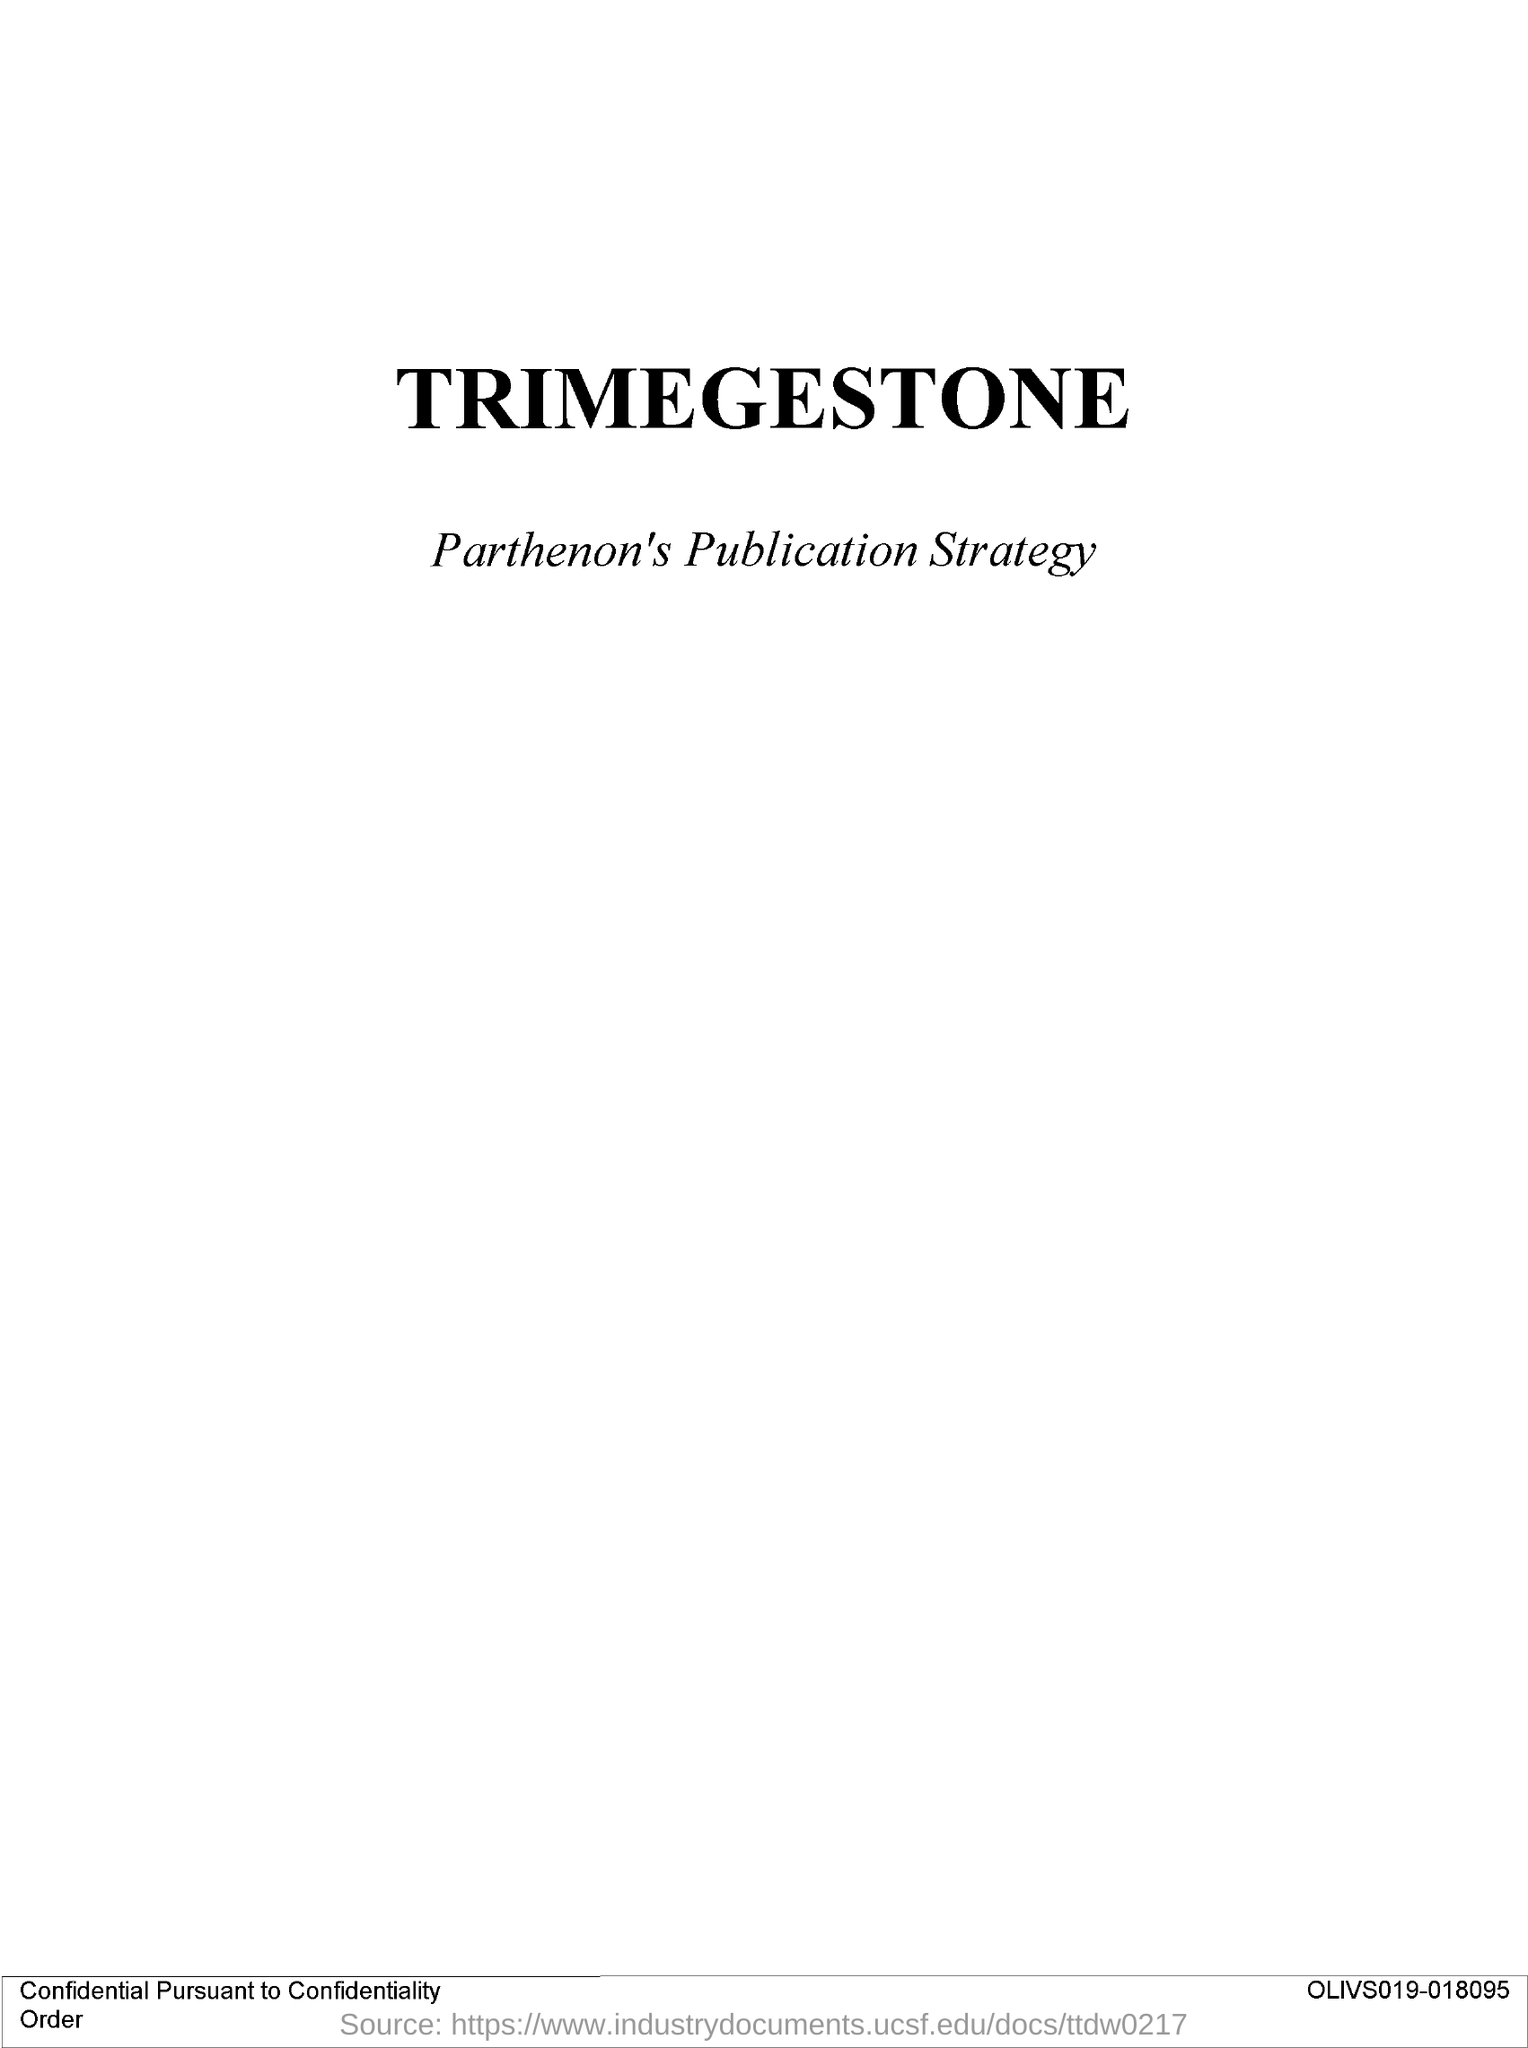What is the Title of the document?
Your answer should be compact. Trimegestone. What is the alphanumerical sequence given at the right bottom?
Offer a terse response. OLIVS019-018095. 